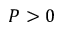<formula> <loc_0><loc_0><loc_500><loc_500>P > 0</formula> 